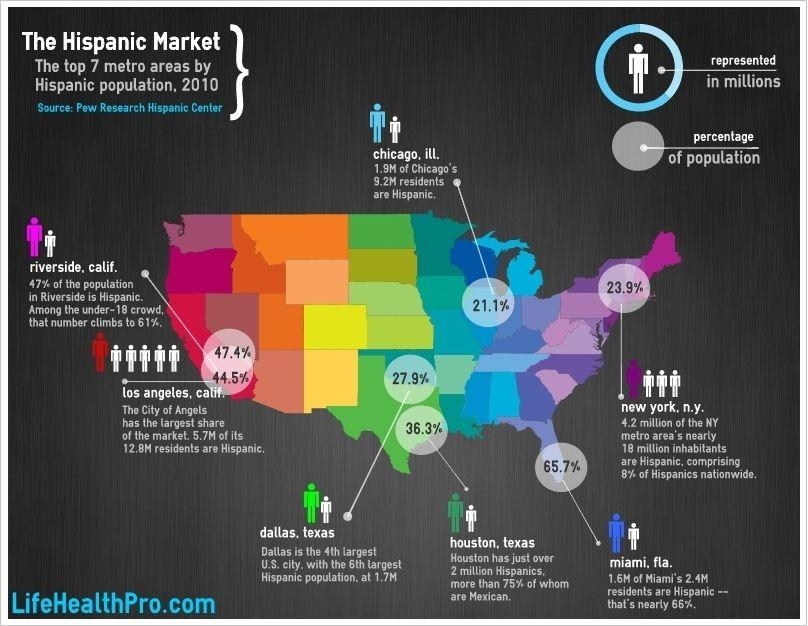Specify some key components in this picture. Approximately 53% of the population in Riverside is not Hispanic. There are approximately 7.1 million non-Hispanic residents living in Los Angeles. According to the information provided, approximately 76.1% of the population of New York is not Hispanic. According to data from the 2020 United States Census, a majority of the population of Chicago, which is 78.9%, is not Hispanic. The number of residents in Chicago who are not Hispanic is approximately 7.3 million. 